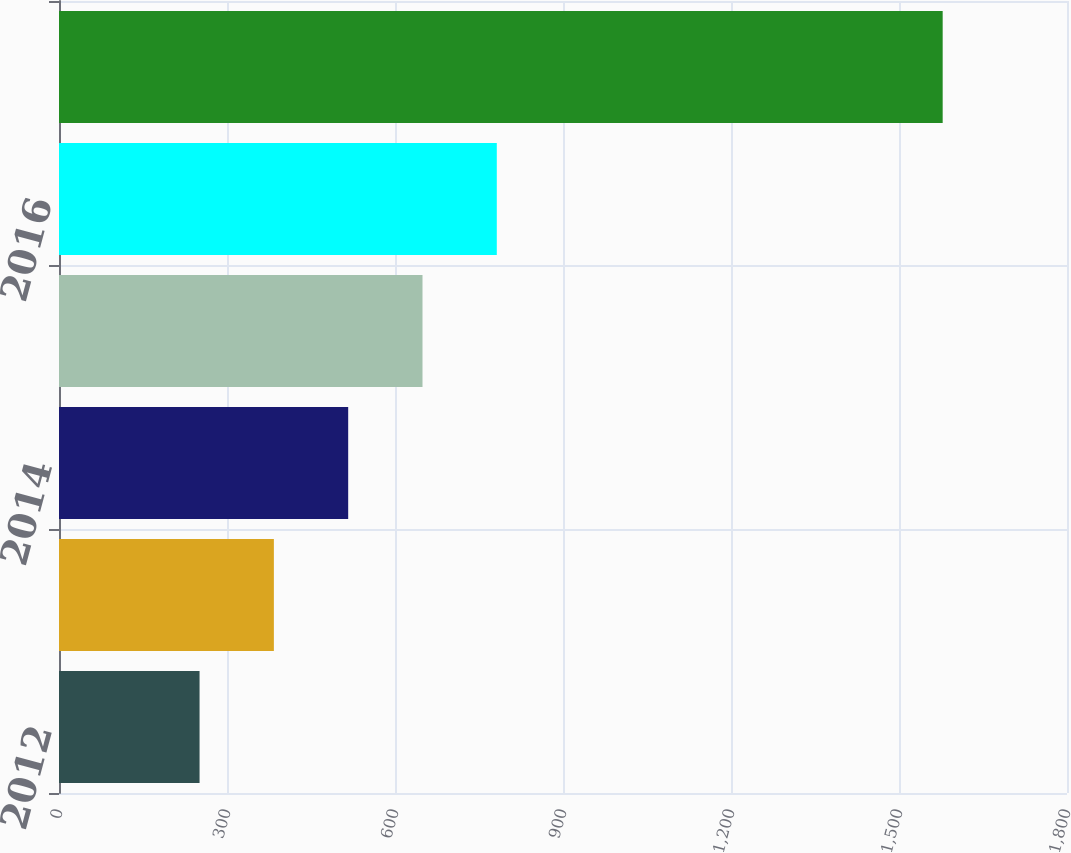Convert chart. <chart><loc_0><loc_0><loc_500><loc_500><bar_chart><fcel>2012<fcel>2013<fcel>2014<fcel>2015<fcel>2016<fcel>2017-2021<nl><fcel>251<fcel>383.7<fcel>516.4<fcel>649.1<fcel>781.8<fcel>1578<nl></chart> 